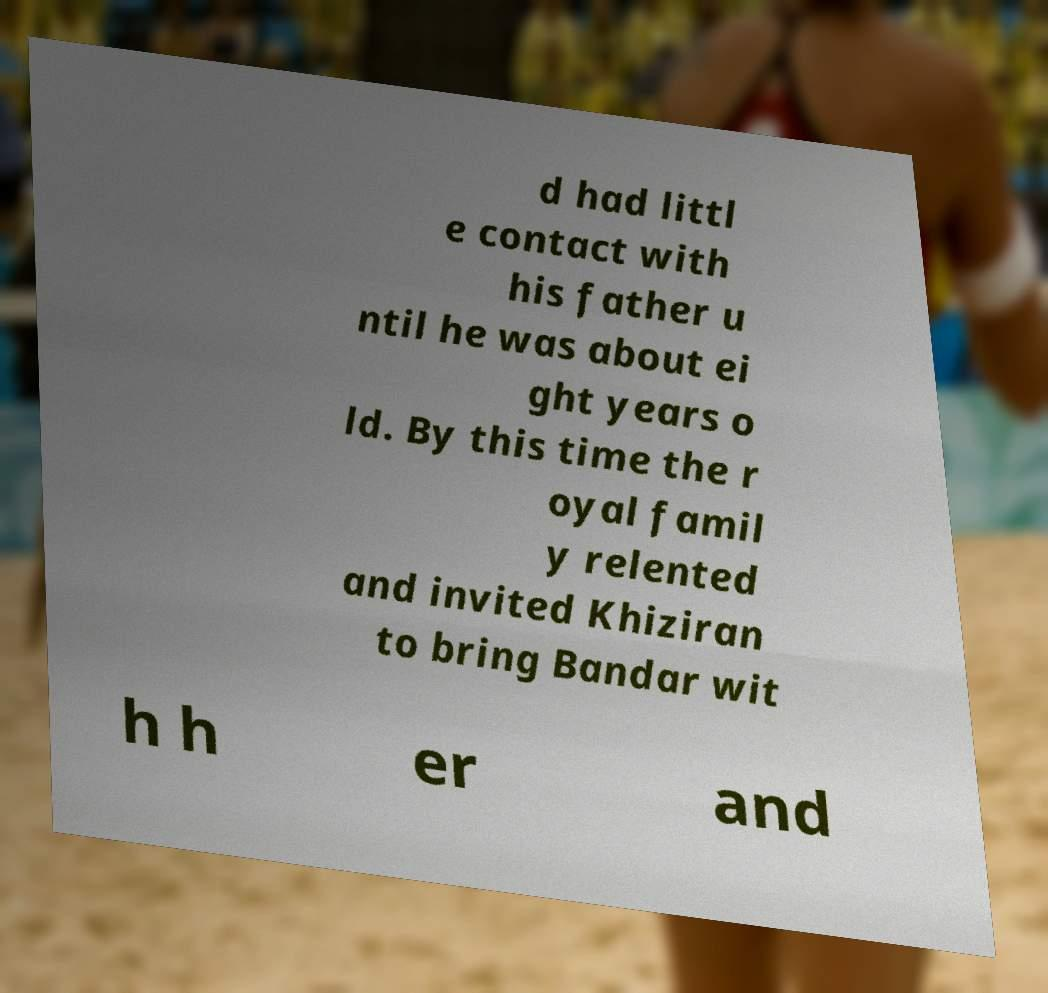Please identify and transcribe the text found in this image. d had littl e contact with his father u ntil he was about ei ght years o ld. By this time the r oyal famil y relented and invited Khiziran to bring Bandar wit h h er and 